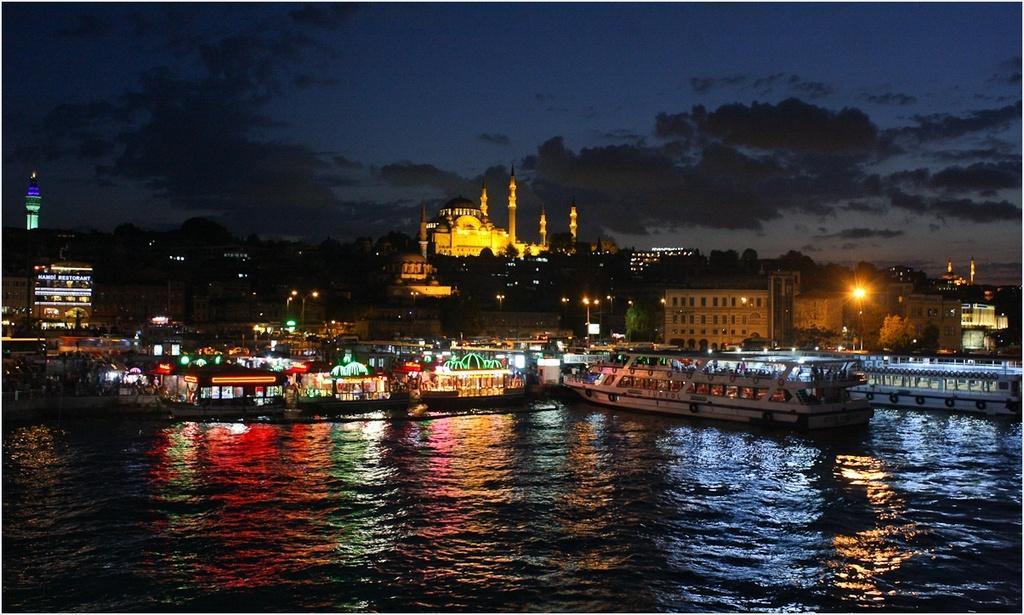Describe this image in one or two sentences. At the bottom I can see water and boats. In the middle I can see light poles, buildings, trees, towers and a mosque. On the top I can see the sky. This image is taken during night. 